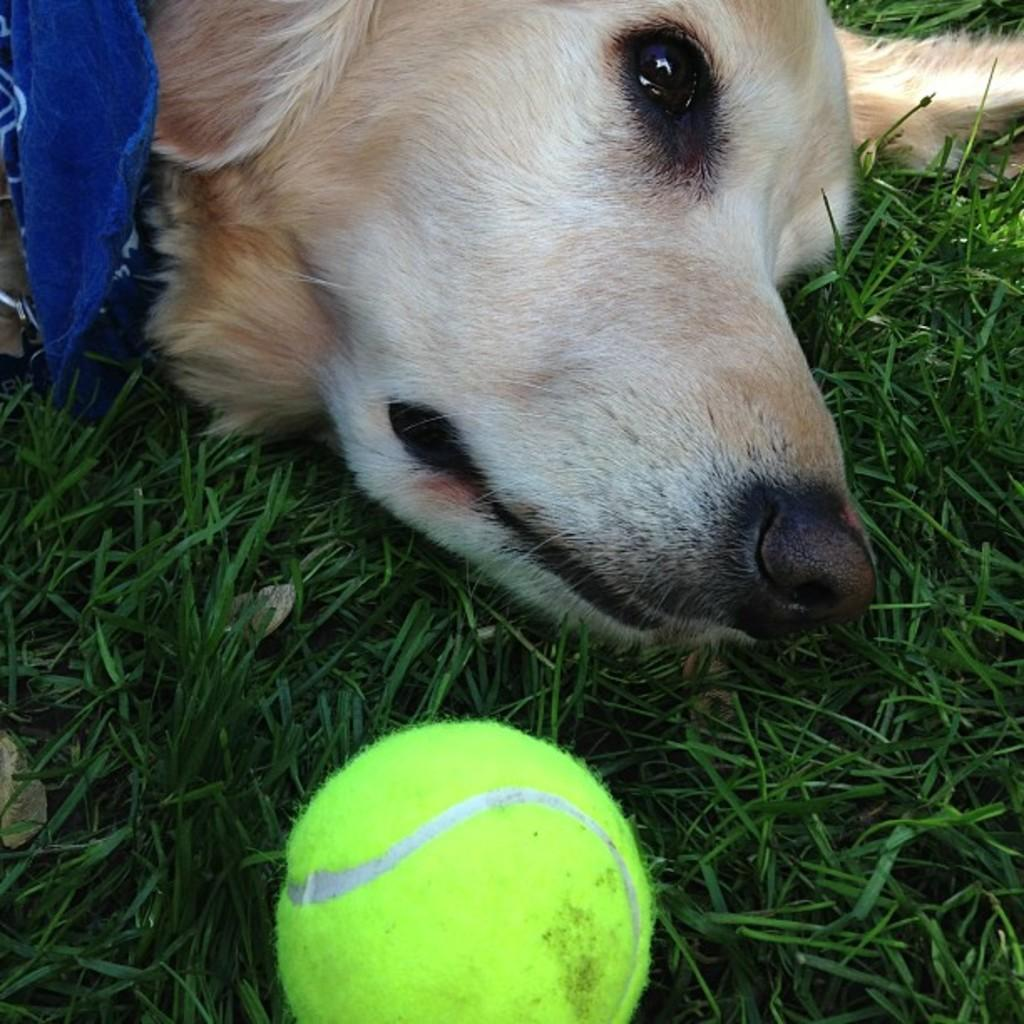What animal is present in the image? There is a dog in the picture. What is the position of the dog's head? The dog's head is laying on the grass. What object is in front of the dog? There is a ball in front of the dog. What type of debt is the dog trying to pay off in the image? There is no mention of debt in the image, and the dog is not engaged in any activity related to debt. 